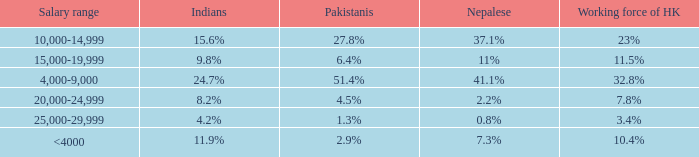If the nepalese is 37.1%, what is the working force of HK? 23%. 